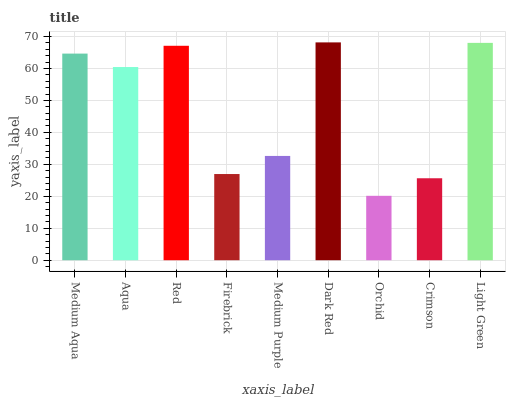Is Aqua the minimum?
Answer yes or no. No. Is Aqua the maximum?
Answer yes or no. No. Is Medium Aqua greater than Aqua?
Answer yes or no. Yes. Is Aqua less than Medium Aqua?
Answer yes or no. Yes. Is Aqua greater than Medium Aqua?
Answer yes or no. No. Is Medium Aqua less than Aqua?
Answer yes or no. No. Is Aqua the high median?
Answer yes or no. Yes. Is Aqua the low median?
Answer yes or no. Yes. Is Red the high median?
Answer yes or no. No. Is Dark Red the low median?
Answer yes or no. No. 